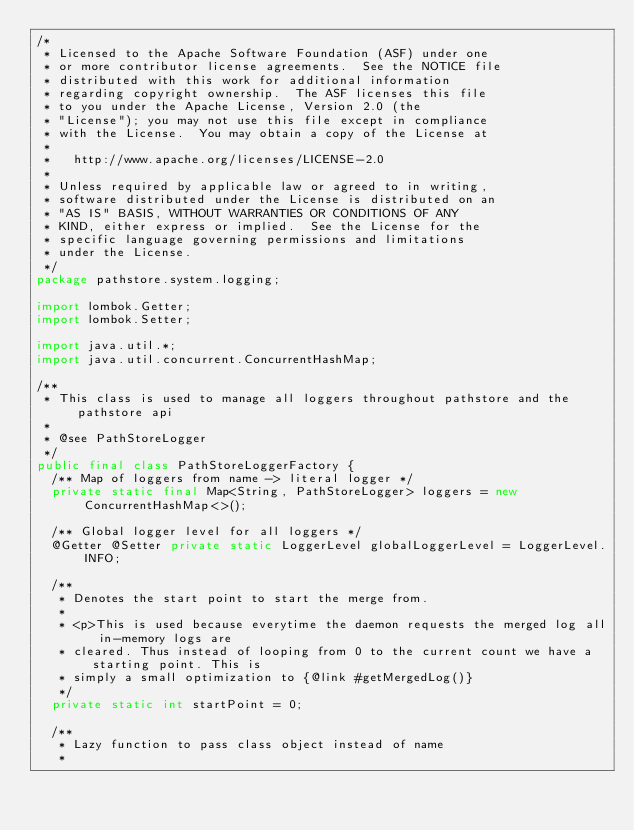<code> <loc_0><loc_0><loc_500><loc_500><_Java_>/*
 * Licensed to the Apache Software Foundation (ASF) under one
 * or more contributor license agreements.  See the NOTICE file
 * distributed with this work for additional information
 * regarding copyright ownership.  The ASF licenses this file
 * to you under the Apache License, Version 2.0 (the
 * "License"); you may not use this file except in compliance
 * with the License.  You may obtain a copy of the License at
 *
 *   http://www.apache.org/licenses/LICENSE-2.0
 *
 * Unless required by applicable law or agreed to in writing,
 * software distributed under the License is distributed on an
 * "AS IS" BASIS, WITHOUT WARRANTIES OR CONDITIONS OF ANY
 * KIND, either express or implied.  See the License for the
 * specific language governing permissions and limitations
 * under the License.
 */
package pathstore.system.logging;

import lombok.Getter;
import lombok.Setter;

import java.util.*;
import java.util.concurrent.ConcurrentHashMap;

/**
 * This class is used to manage all loggers throughout pathstore and the pathstore api
 *
 * @see PathStoreLogger
 */
public final class PathStoreLoggerFactory {
  /** Map of loggers from name -> literal logger */
  private static final Map<String, PathStoreLogger> loggers = new ConcurrentHashMap<>();

  /** Global logger level for all loggers */
  @Getter @Setter private static LoggerLevel globalLoggerLevel = LoggerLevel.INFO;

  /**
   * Denotes the start point to start the merge from.
   *
   * <p>This is used because everytime the daemon requests the merged log all in-memory logs are
   * cleared. Thus instead of looping from 0 to the current count we have a starting point. This is
   * simply a small optimization to {@link #getMergedLog()}
   */
  private static int startPoint = 0;

  /**
   * Lazy function to pass class object instead of name
   *</code> 